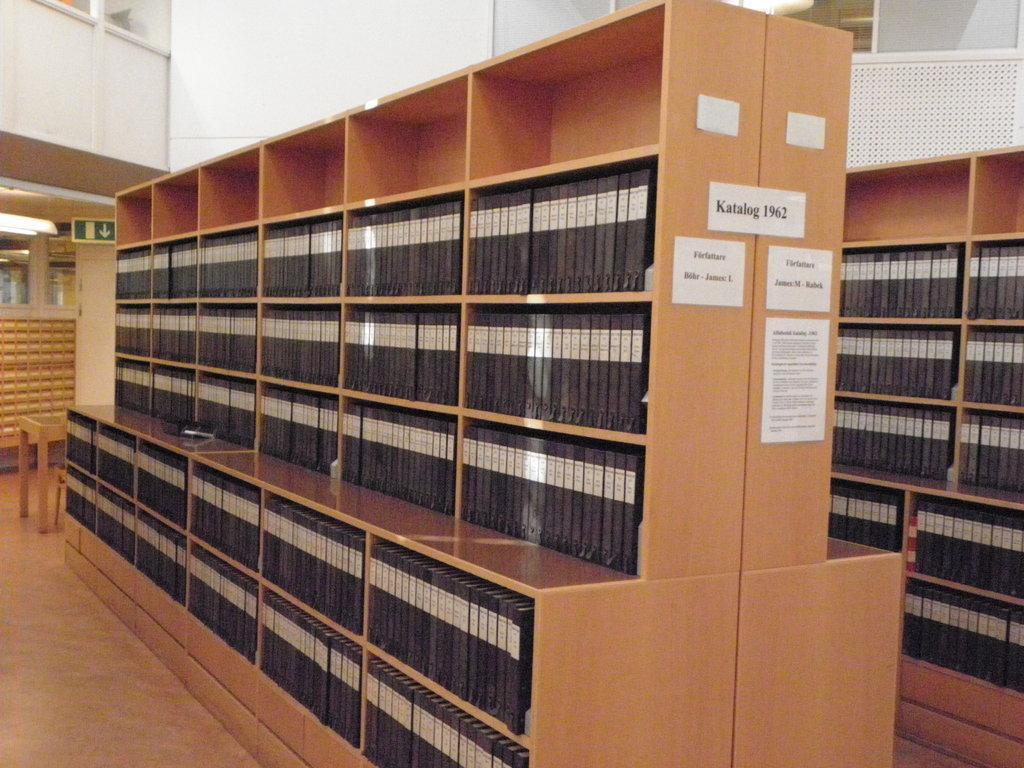Describe this image in one or two sentences. In this image we can see the inner view of a building and there are two racks with some objects and the objects looks like books and on one rack there are some papers with text. 